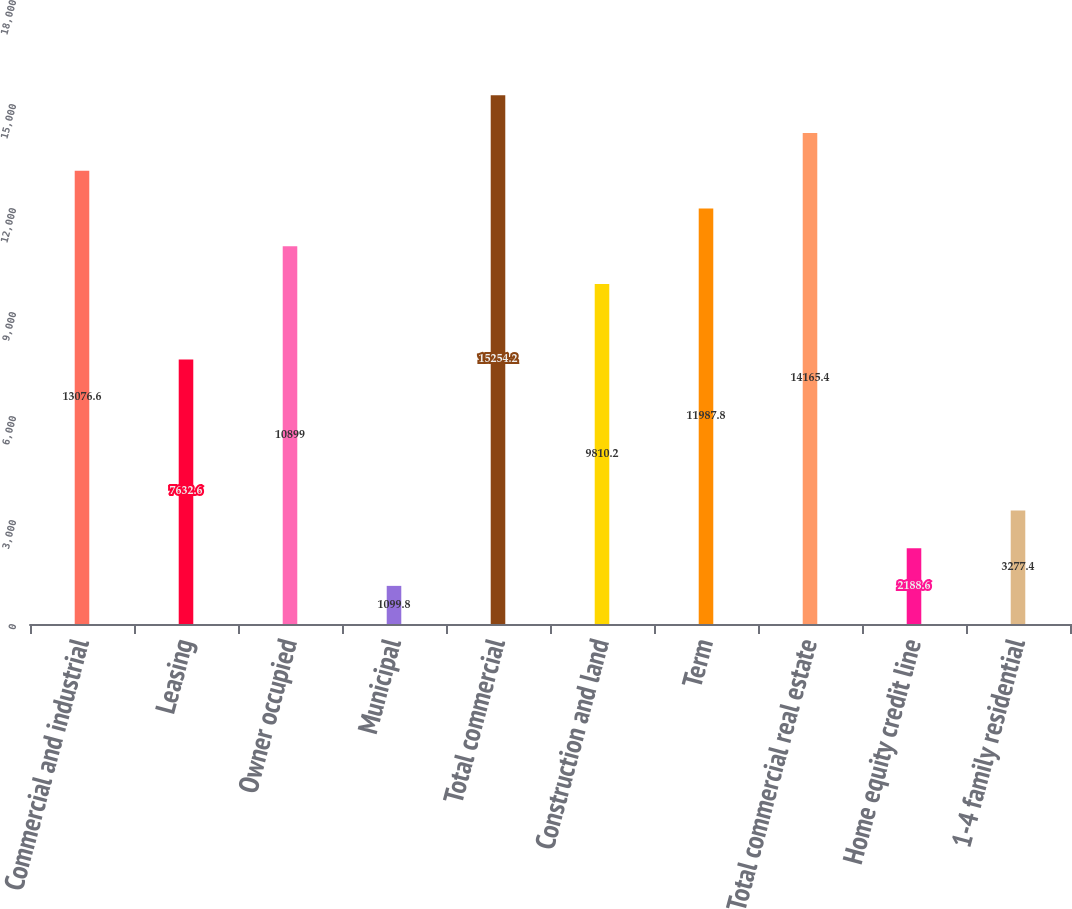Convert chart to OTSL. <chart><loc_0><loc_0><loc_500><loc_500><bar_chart><fcel>Commercial and industrial<fcel>Leasing<fcel>Owner occupied<fcel>Municipal<fcel>Total commercial<fcel>Construction and land<fcel>Term<fcel>Total commercial real estate<fcel>Home equity credit line<fcel>1-4 family residential<nl><fcel>13076.6<fcel>7632.6<fcel>10899<fcel>1099.8<fcel>15254.2<fcel>9810.2<fcel>11987.8<fcel>14165.4<fcel>2188.6<fcel>3277.4<nl></chart> 